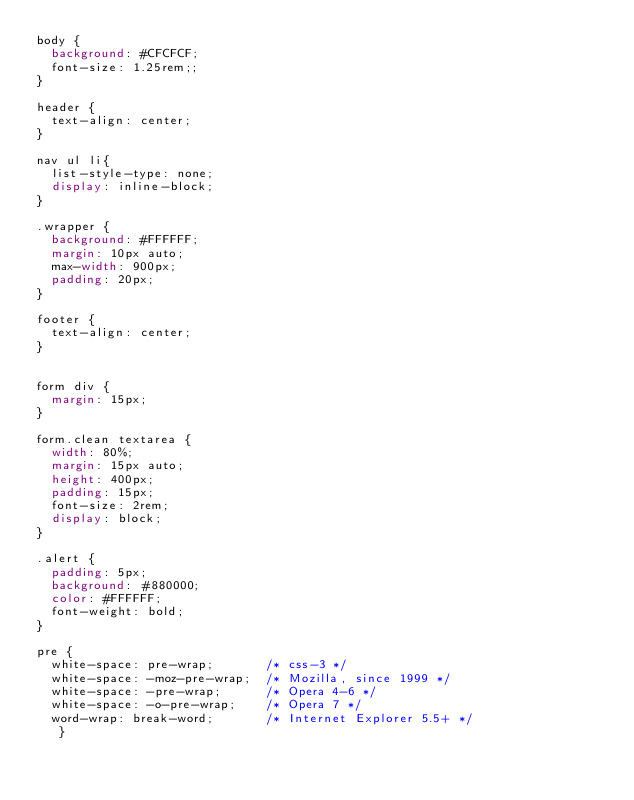Convert code to text. <code><loc_0><loc_0><loc_500><loc_500><_CSS_>body {
	background: #CFCFCF;
	font-size: 1.25rem;;
}

header {
	text-align: center;
}

nav ul li{
	list-style-type: none;
	display: inline-block;
}

.wrapper {
	background: #FFFFFF;
	margin: 10px auto;
	max-width: 900px;
	padding: 20px;
}

footer {
	text-align: center;
}


form div {
	margin: 15px;
}

form.clean textarea {
	width: 80%;
	margin: 15px auto;
	height: 400px;
	padding: 15px;
	font-size: 2rem;
	display: block;
}

.alert {
	padding: 5px;
	background: #880000;
	color: #FFFFFF;
	font-weight: bold;
}

pre {
	white-space: pre-wrap;       /* css-3 */
	white-space: -moz-pre-wrap;  /* Mozilla, since 1999 */
	white-space: -pre-wrap;      /* Opera 4-6 */
	white-space: -o-pre-wrap;    /* Opera 7 */
	word-wrap: break-word;       /* Internet Explorer 5.5+ */
   }</code> 